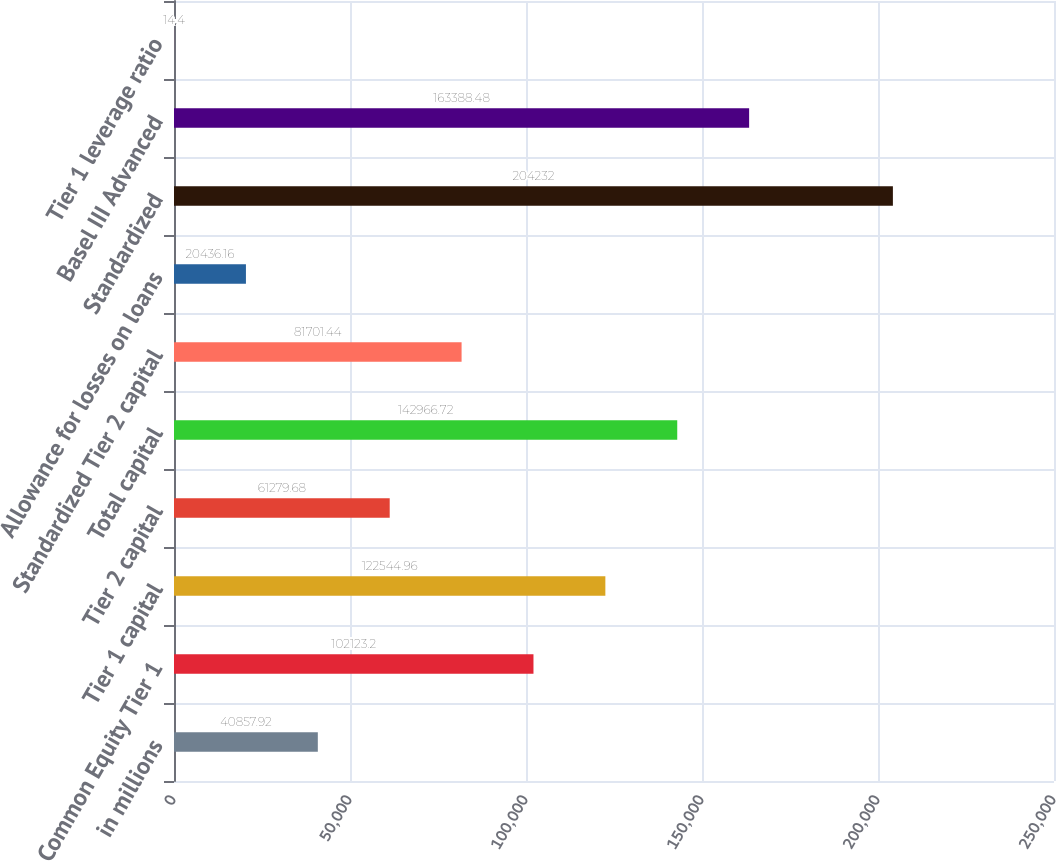<chart> <loc_0><loc_0><loc_500><loc_500><bar_chart><fcel>in millions<fcel>Common Equity Tier 1<fcel>Tier 1 capital<fcel>Tier 2 capital<fcel>Total capital<fcel>Standardized Tier 2 capital<fcel>Allowance for losses on loans<fcel>Standardized<fcel>Basel III Advanced<fcel>Tier 1 leverage ratio<nl><fcel>40857.9<fcel>102123<fcel>122545<fcel>61279.7<fcel>142967<fcel>81701.4<fcel>20436.2<fcel>204232<fcel>163388<fcel>14.4<nl></chart> 